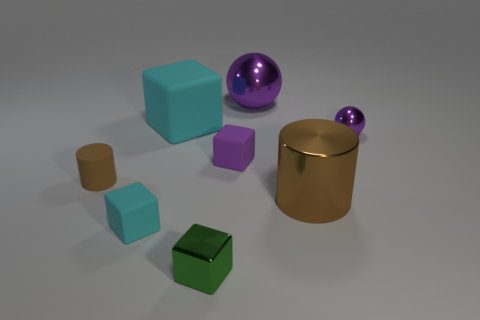What is the shape of the big metallic thing that is the same color as the rubber cylinder?
Provide a succinct answer. Cylinder. How many other green metallic objects are the same shape as the small green shiny object?
Give a very brief answer. 0. There is a brown thing that is the same material as the tiny sphere; what is its size?
Your answer should be compact. Large. Are there the same number of small brown rubber things behind the purple matte block and tiny purple shiny balls?
Your response must be concise. No. Is the big rubber cube the same color as the big sphere?
Offer a very short reply. No. Do the big metal object that is behind the big brown thing and the cyan rubber object that is behind the large brown metallic object have the same shape?
Ensure brevity in your answer.  No. There is another cyan object that is the same shape as the large cyan object; what is it made of?
Ensure brevity in your answer.  Rubber. There is a large thing that is to the right of the tiny green shiny thing and behind the small ball; what is its color?
Your response must be concise. Purple. There is a metal cylinder that is in front of the matte thing that is behind the tiny purple ball; are there any tiny cubes that are in front of it?
Give a very brief answer. Yes. How many objects are brown cylinders or purple metallic spheres?
Your response must be concise. 4. 